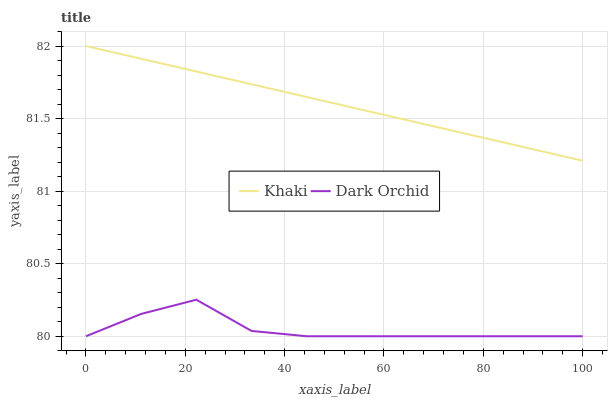Does Dark Orchid have the minimum area under the curve?
Answer yes or no. Yes. Does Khaki have the maximum area under the curve?
Answer yes or no. Yes. Does Dark Orchid have the maximum area under the curve?
Answer yes or no. No. Is Khaki the smoothest?
Answer yes or no. Yes. Is Dark Orchid the roughest?
Answer yes or no. Yes. Is Dark Orchid the smoothest?
Answer yes or no. No. Does Dark Orchid have the lowest value?
Answer yes or no. Yes. Does Khaki have the highest value?
Answer yes or no. Yes. Does Dark Orchid have the highest value?
Answer yes or no. No. Is Dark Orchid less than Khaki?
Answer yes or no. Yes. Is Khaki greater than Dark Orchid?
Answer yes or no. Yes. Does Dark Orchid intersect Khaki?
Answer yes or no. No. 